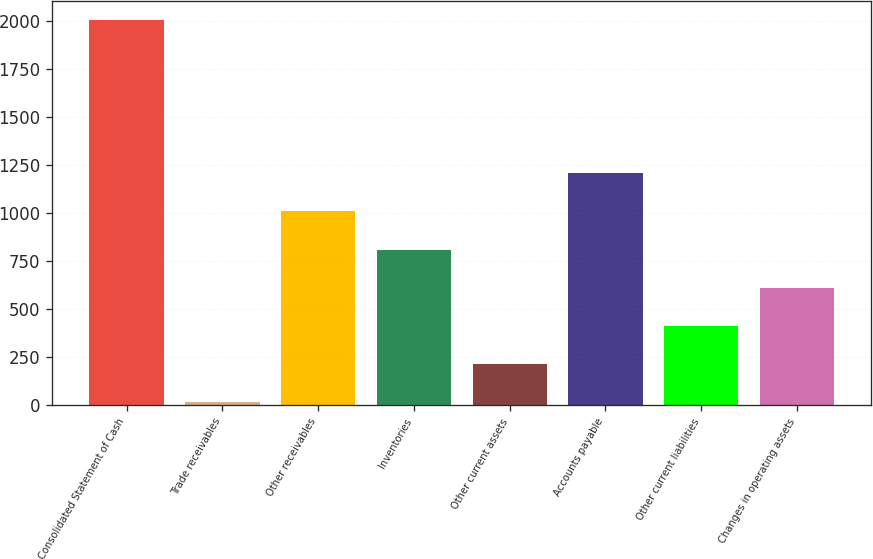Convert chart. <chart><loc_0><loc_0><loc_500><loc_500><bar_chart><fcel>Consolidated Statement of Cash<fcel>Trade receivables<fcel>Other receivables<fcel>Inventories<fcel>Other current assets<fcel>Accounts payable<fcel>Other current liabilities<fcel>Changes in operating assets<nl><fcel>2004<fcel>13.8<fcel>1008.9<fcel>809.88<fcel>212.82<fcel>1207.92<fcel>411.84<fcel>610.86<nl></chart> 